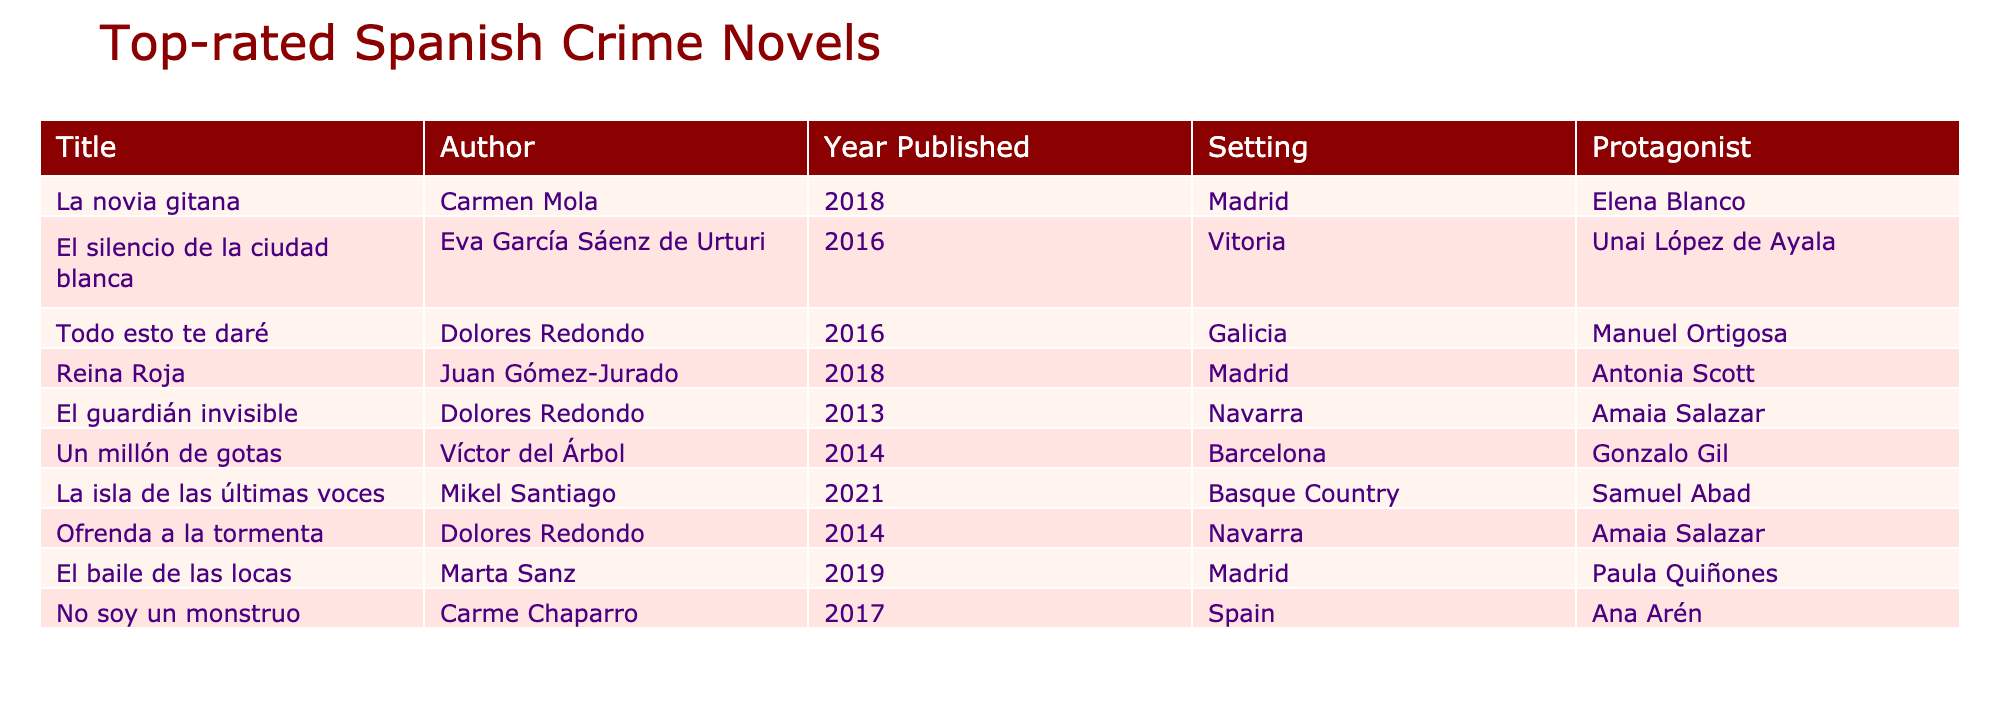What is the title of the book written by Carmen Mola? The table lists the books along with their authors. Looking for "Carmen Mola" under the Author column, we find that the title next to her name is "La novia gitana."
Answer: La novia gitana Which novel features a protagonist named Amaia Salazar? To find the novel with the protagonist Amaia Salazar, we can scan through the Protagonist column. We see that both "El guardián invisible" and "Ofrenda a la tormenta" have Amaia Salazar as the protagonist.
Answer: El guardián invisible, Ofrenda a la tormenta How many novels were published in Madrid? By looking at the Setting column, we count all entries with "Madrid," which are "La novia gitana," "Reina Roja," and "El baile de las locas." Therefore, there are three novels published in Madrid.
Answer: 3 Is there a novel set in Galicia? Checking the Setting column, we see that "Todo esto te daré" is listed under Galicia. Thus, there is at least one novel set in that region.
Answer: Yes Which author has written the most novels in this list? We examine the Author column for repetitions. We see Dolores Redondo appears three times with "Todo esto te daré," "El guardián invisible," and "Ofrenda a la tormenta." Therefore, she has the most novels listed.
Answer: Dolores Redondo What is the average publication year of the novels in this list? We add up the years published (2018 + 2016 + 2016 + 2018 + 2013 + 2014 + 2021 + 2014 + 2019 + 2017 = 2016.9) and divide by the number of novels (10). This gives us an average year of approximately 2016.9.
Answer: 2016.9 How many novels feature protagonists with female names? Reviewing the Protagonist column, we find the names: Elena Blanco, Unai López de Ayala, Manuel Ortigosa, Antonia Scott, Amaia Salazar, Gonzalo Gil, Samuel Abad, Paula Quiñones, and Ana Arén. Out of these, we identify Elena Blanco, Antonia Scott, Amaia Salazar, Paula Quiñones, and Ana Arén as female, totaling five.
Answer: 5 Is "La isla de las últimas voces" set in the Basque Country? In the Setting column, we look for "La isla de las últimas voces" and confirm that it is indeed listed under Basque Country. Thus, the statement is true.
Answer: Yes Which novel has the protagonist named Antonia Scott? Inspecting the Protagonist column, we see that the novel associated with Antonia Scott is "Reina Roja."
Answer: Reina Roja 